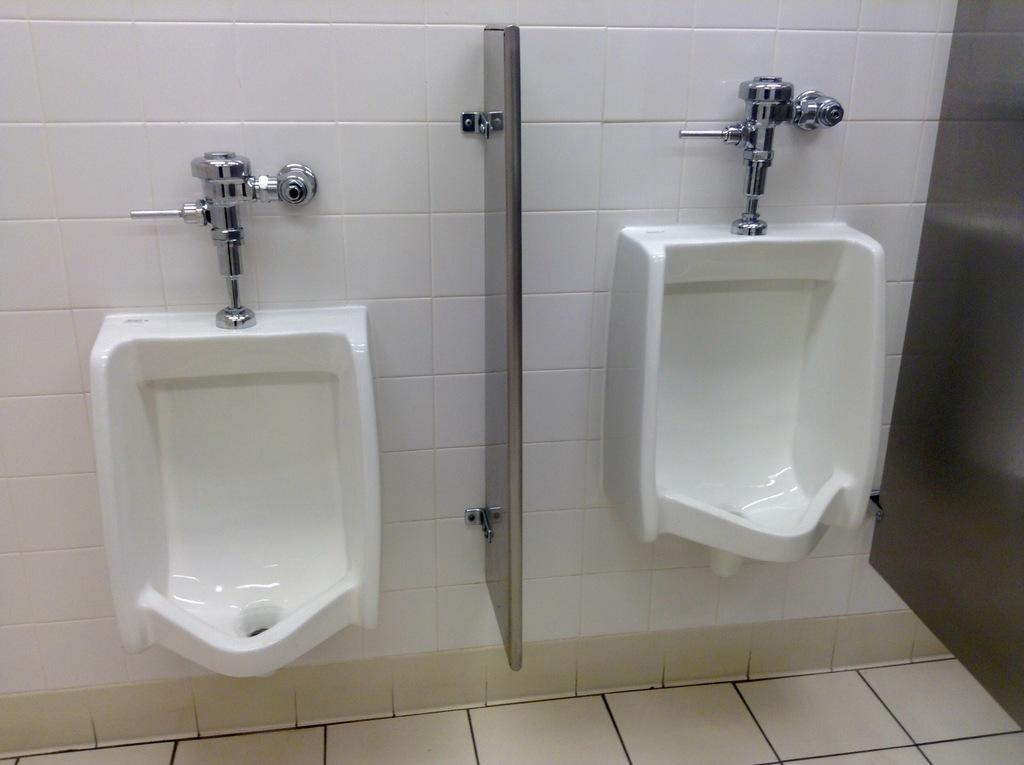Describe this image in one or two sentences. In the image there are two toilet basins on the wall with a partition in the middle. 